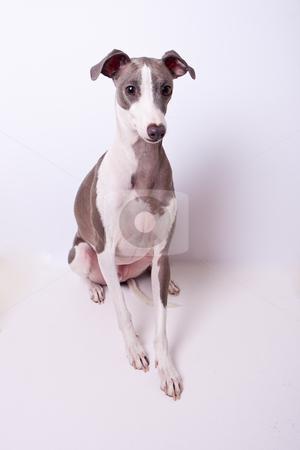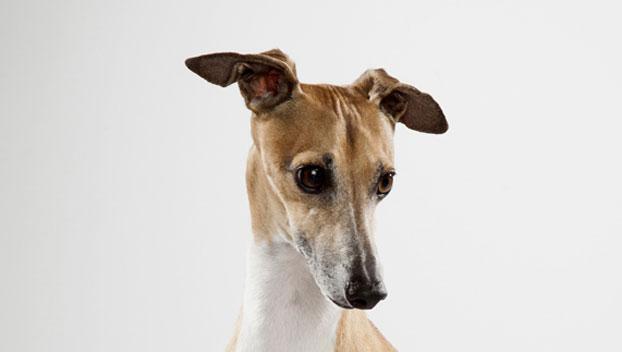The first image is the image on the left, the second image is the image on the right. Assess this claim about the two images: "All dog legs are visible and no dog is sitting or laying down.". Correct or not? Answer yes or no. No. 